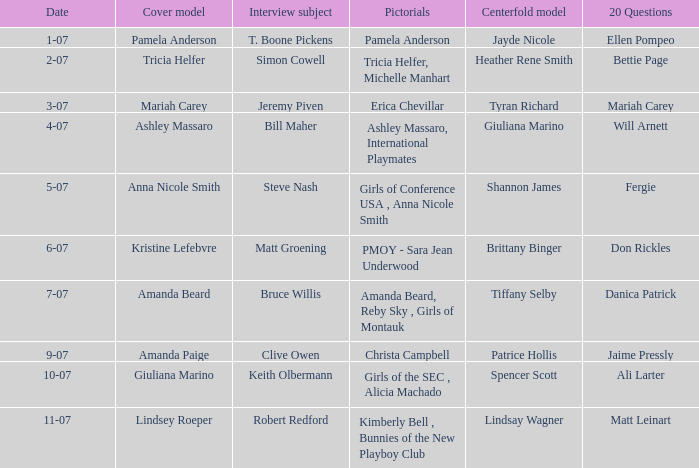Who was the centerfold model when the issue's pictorial was kimberly bell , bunnies of the new playboy club? Lindsay Wagner. 